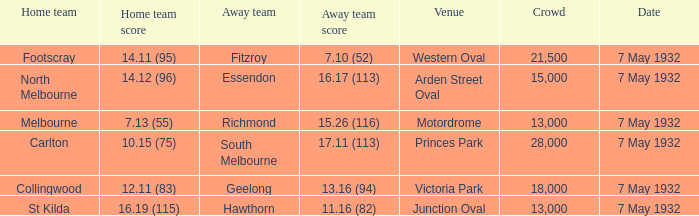What is the home team for victoria park? Collingwood. 